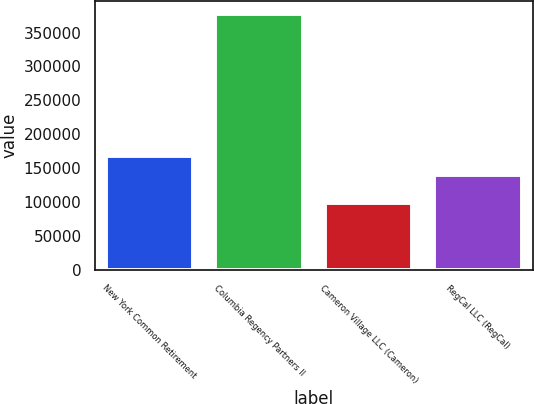Convert chart to OTSL. <chart><loc_0><loc_0><loc_500><loc_500><bar_chart><fcel>New York Common Retirement<fcel>Columbia Regency Partners II<fcel>Cameron Village LLC (Cameron)<fcel>RegCal LLC (RegCal)<nl><fcel>167693<fcel>377121<fcel>98633<fcel>139844<nl></chart> 